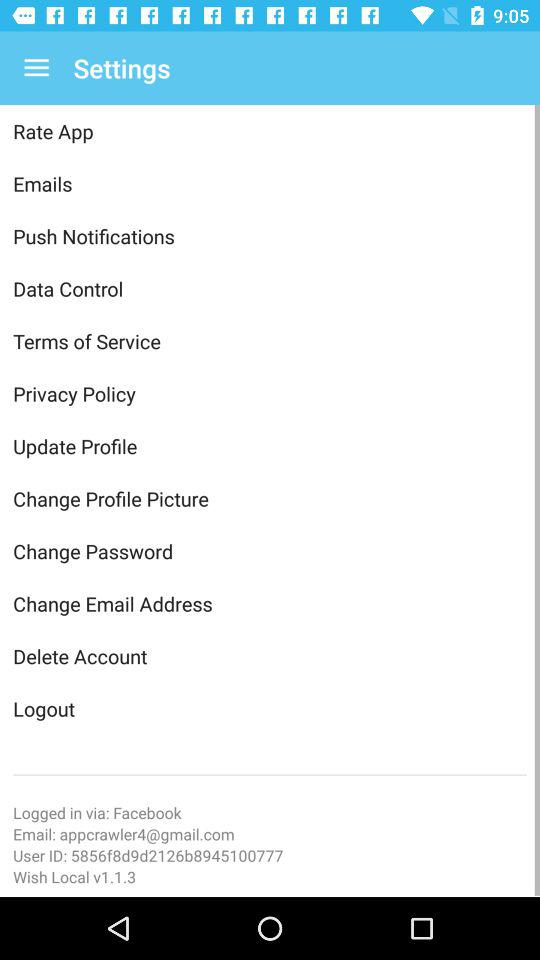We can login via what social media? You can login with "Facebook". 